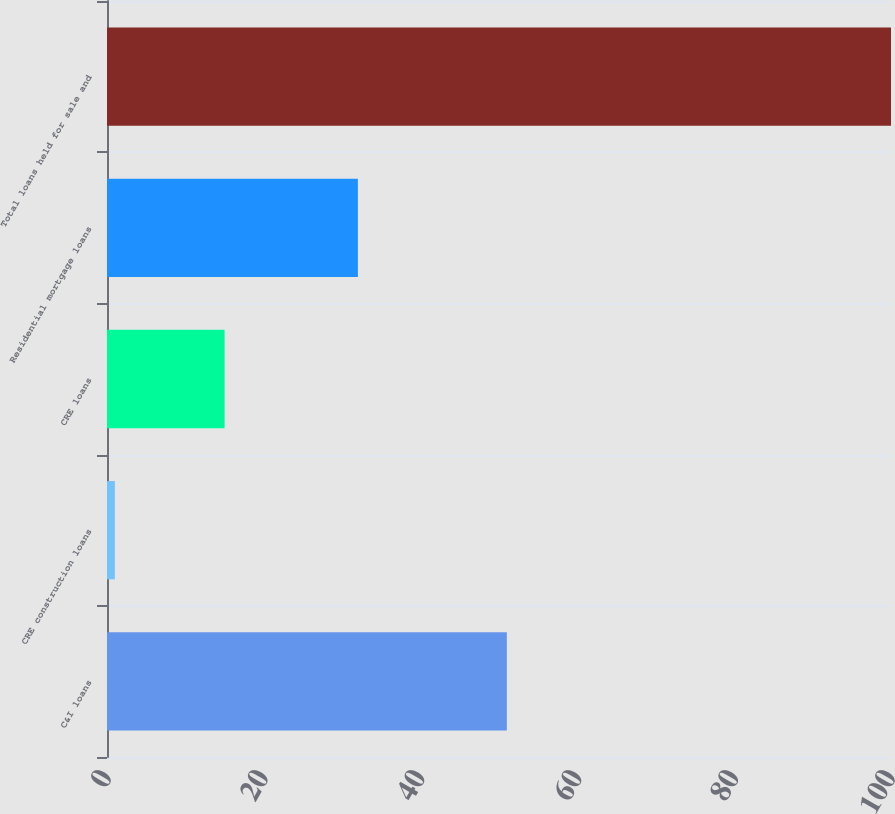<chart> <loc_0><loc_0><loc_500><loc_500><bar_chart><fcel>C&I loans<fcel>CRE construction loans<fcel>CRE loans<fcel>Residential mortgage loans<fcel>Total loans held for sale and<nl><fcel>51<fcel>1<fcel>15<fcel>32<fcel>100<nl></chart> 